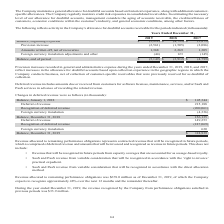According to Aci Worldwide's financial document, What does the company consider in estimating the necessary level of allowance for doubtful accounts? the aging of accounts receivable, the creditworthiness of customers, economic conditions within the customer’s industry, and general economic conditions, among other factors.. The document states: "owance for doubtful accounts, management considers the aging of accounts receivable, the creditworthiness of customers, economic conditions within the..." Also, What was the balance at the end of period in 2019? Based on the financial document, the answer is -$5,149 (in thousands). Also, What was the balance at the end of period in 2018? Based on the financial document, the answer is -$3,912 (in thousands). Also, can you calculate: What was the change in balance at the end of period between 2018 and 2019? Based on the calculation: -$5,149+3,912, the result is -1237 (in thousands). This is based on the information: "Balance, beginning of period $ (3,912 ) $ (4,799 ) $ (3,873 ) Balance, end of period $ (5,149 ) $ (3,912 ) $ (4,799 )..." The key data points involved are: 3,912, 5,149. Also, can you calculate: What was the change in Amounts written off, net of recoveries between 2018 and 2019? Based on the calculation: 1,368-2,269, the result is -901 (in thousands). This is based on the information: "Amounts written off, net of recoveries 1,368 2,269 1,305 Amounts written off, net of recoveries 1,368 2,269 1,305..." The key data points involved are: 1,368, 2,269. Also, can you calculate: What was the percentage change in Amounts written off, net of recoveries between 2017 and 2018? To answer this question, I need to perform calculations using the financial data. The calculation is: (2,269-1,305)/1,305, which equals 73.87 (percentage). This is based on the information: "Amounts written off, net of recoveries 1,368 2,269 1,305 mounts written off, net of recoveries 1,368 2,269 1,305..." The key data points involved are: 1,305, 2,269. 